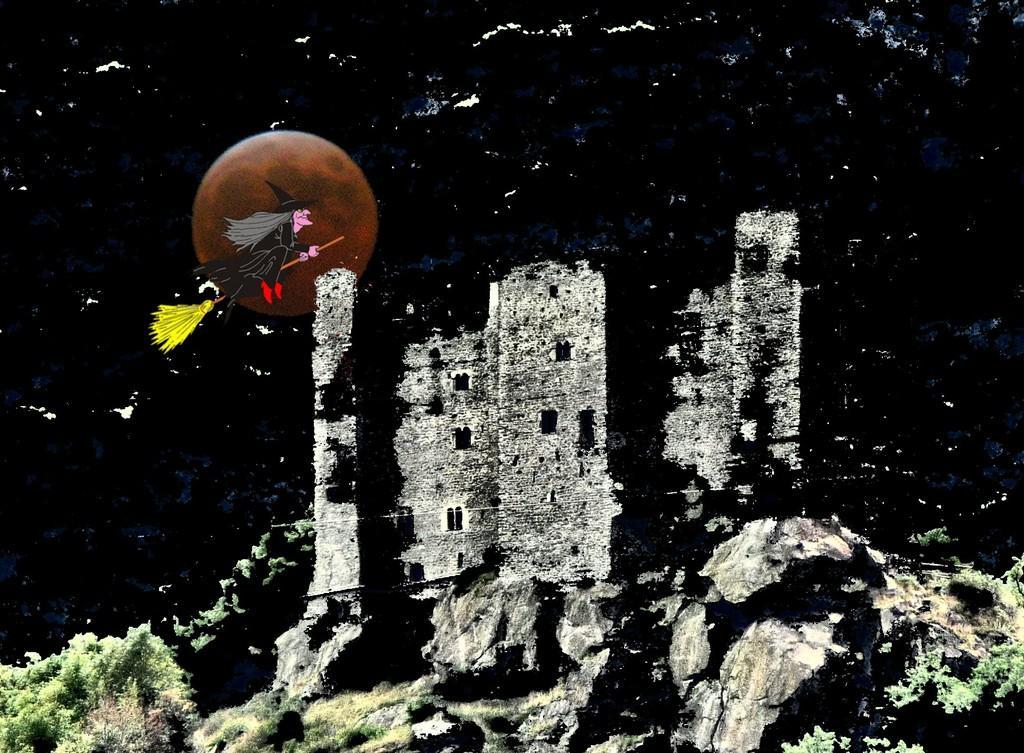How would you summarize this image in a sentence or two? This is an animated picture. In the foreground of the picture there are trees, rocks and a castle. In the middle of the picture we can see a person flying using a broomstick and there is moon in the sky. At the top it is black. 